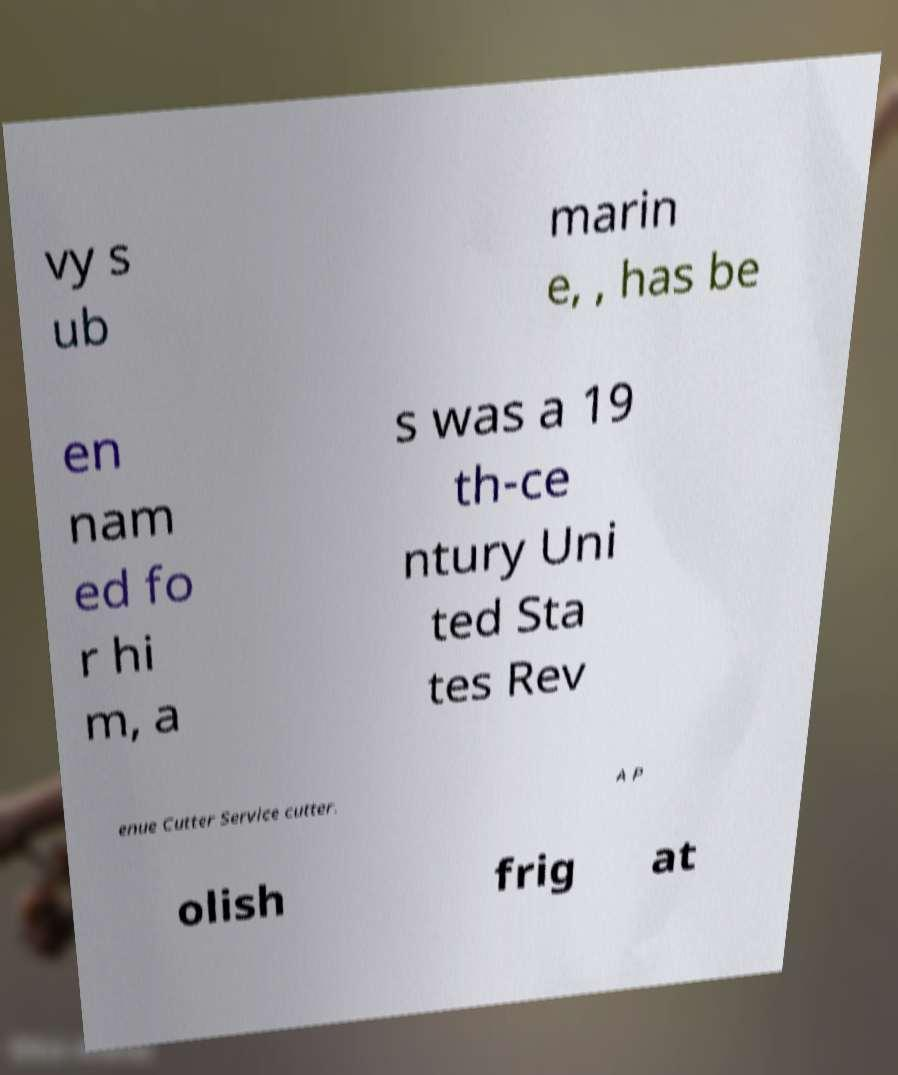Please identify and transcribe the text found in this image. vy s ub marin e, , has be en nam ed fo r hi m, a s was a 19 th-ce ntury Uni ted Sta tes Rev enue Cutter Service cutter. A P olish frig at 